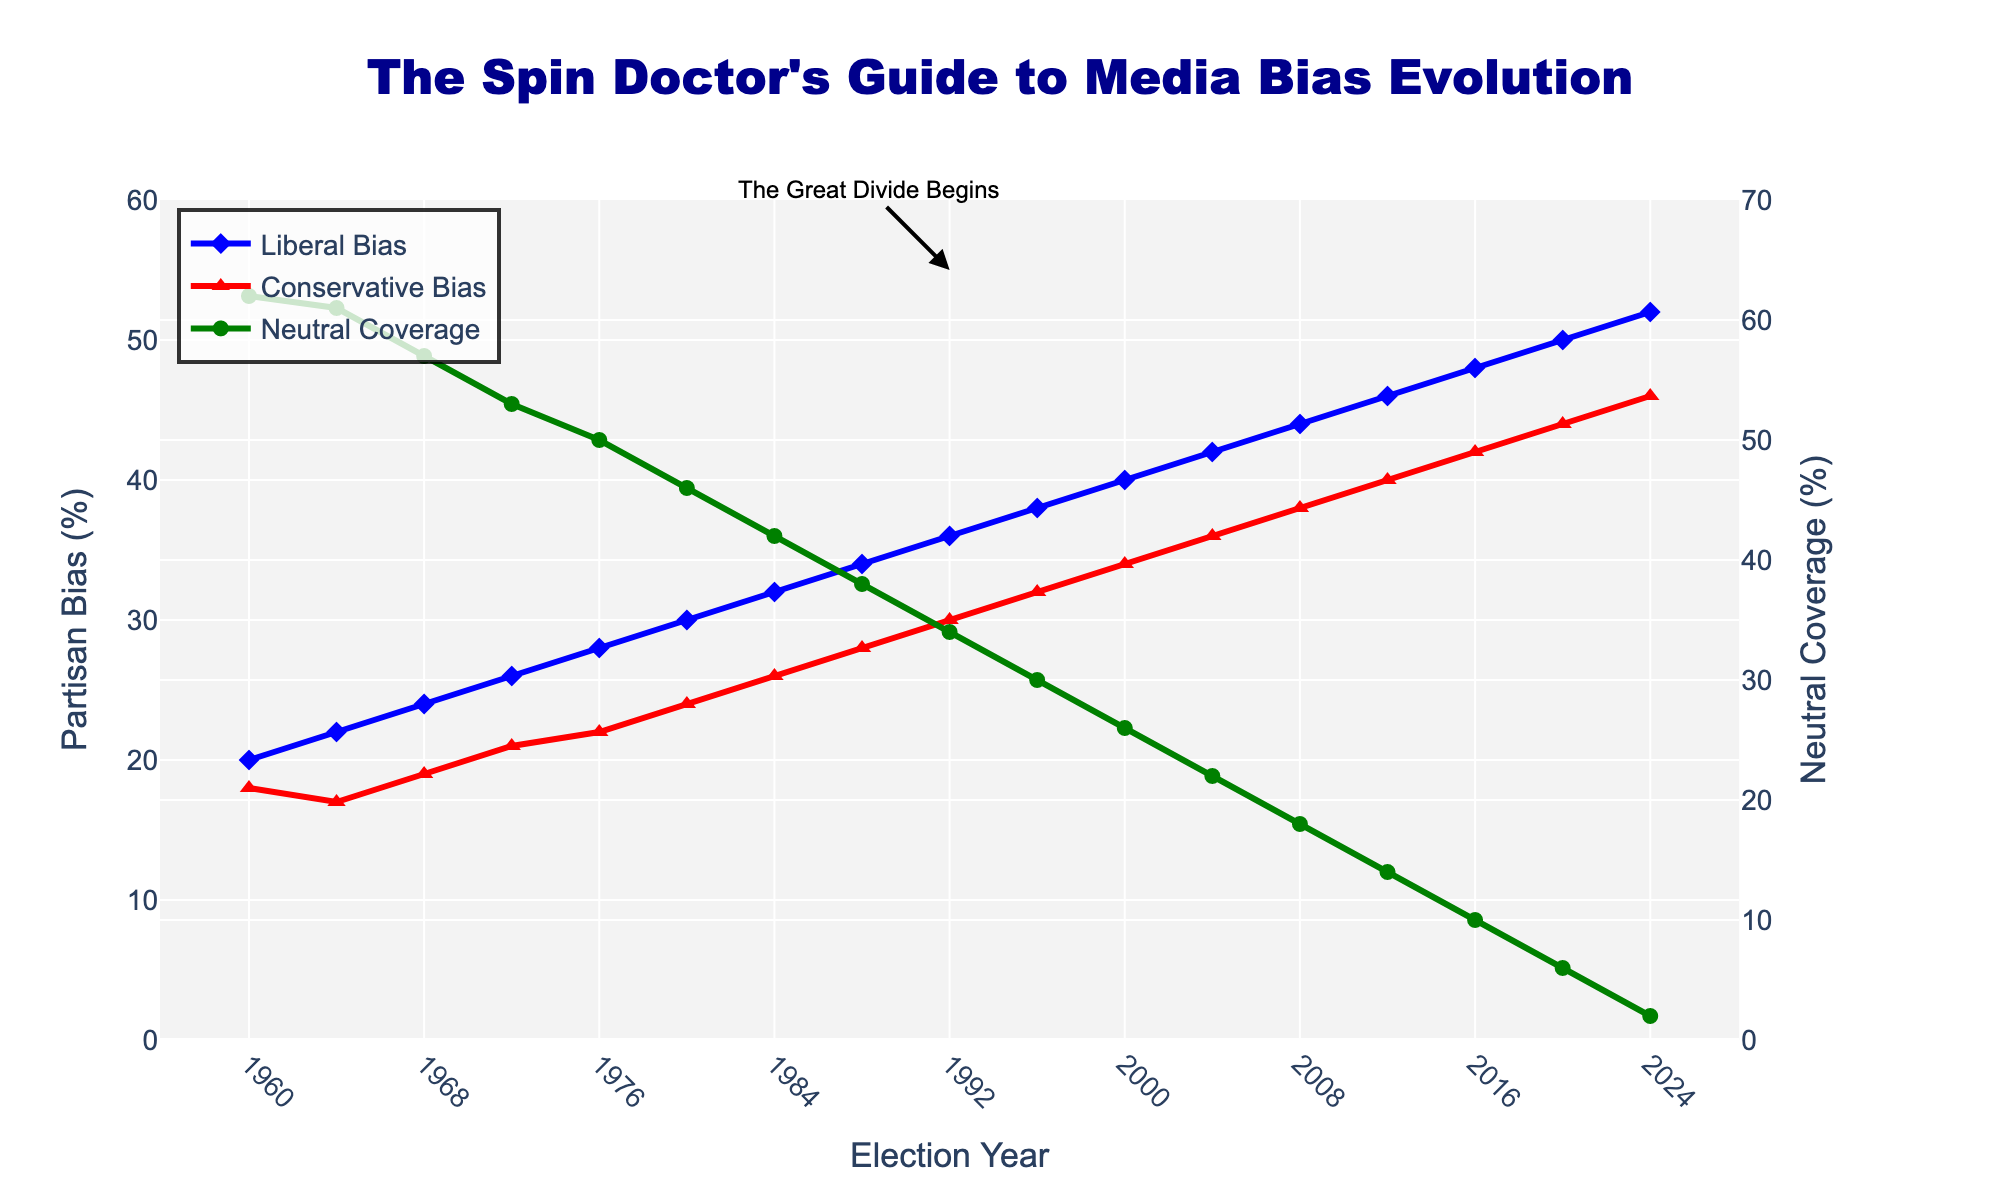Which year did the Neutral Coverage percentage fall below 50% for the first time? From the chart, we can see that Neutral Coverage was consistently above 50% until 1972. In 1976, it fell to 50%, and from 1980 onwards, it dropped below 50%.
Answer: 1980 Between 1984 and 2000, which year recorded the highest Conservative Bias? By observing the chart for the years 1984 to 2000, we see that the highest Conservative Bias was recorded in the year 2000, with a value of 34%.
Answer: 2000 What is the difference in the Neutral Coverage percentage between 1968 and 2008? Neutral Coverage was 57% in 1968 and 18% in 2008. The difference would be 57% - 18% = 39%.
Answer: 39% In which year is the gap between Liberal Bias and Conservative Bias the smallest, before 2024? Inspecting the chart closely, the smallest gap before 2024 appears in 1964, where the difference is 22% (Liberal Bias) - 17% (Conservative Bias) = 5%.
Answer: 1964 What trend is observed in the Liberal Bias from 1960 to 2024? The chart shows an upward trend in Liberal Bias from 20% in 1960 to 52% in 2024.
Answer: Increasing Which visual marker represents the highest data point for Conservative Bias, and in what year? The visual marker for Conservative Bias is a red triangle. The highest data point (46%) occurs in the year 2024.
Answer: Red triangle in 2024 Calculate the average of Neutral Coverage percentages for the years 1980, 1992, and 2008. The values for Neutral Coverage in 1980, 1992, and 2008 are 46%, 34%, and 18%, respectively. The average is (46 + 34 + 18) / 3 = 32.67%.
Answer: 32.67% Has Liberal Bias ever decreased from one election to the next within the timeframe shown? No, the chart shows a continuous increase in Liberal Bias from 1960 to 2024, with no decreases observed between any election years.
Answer: No 